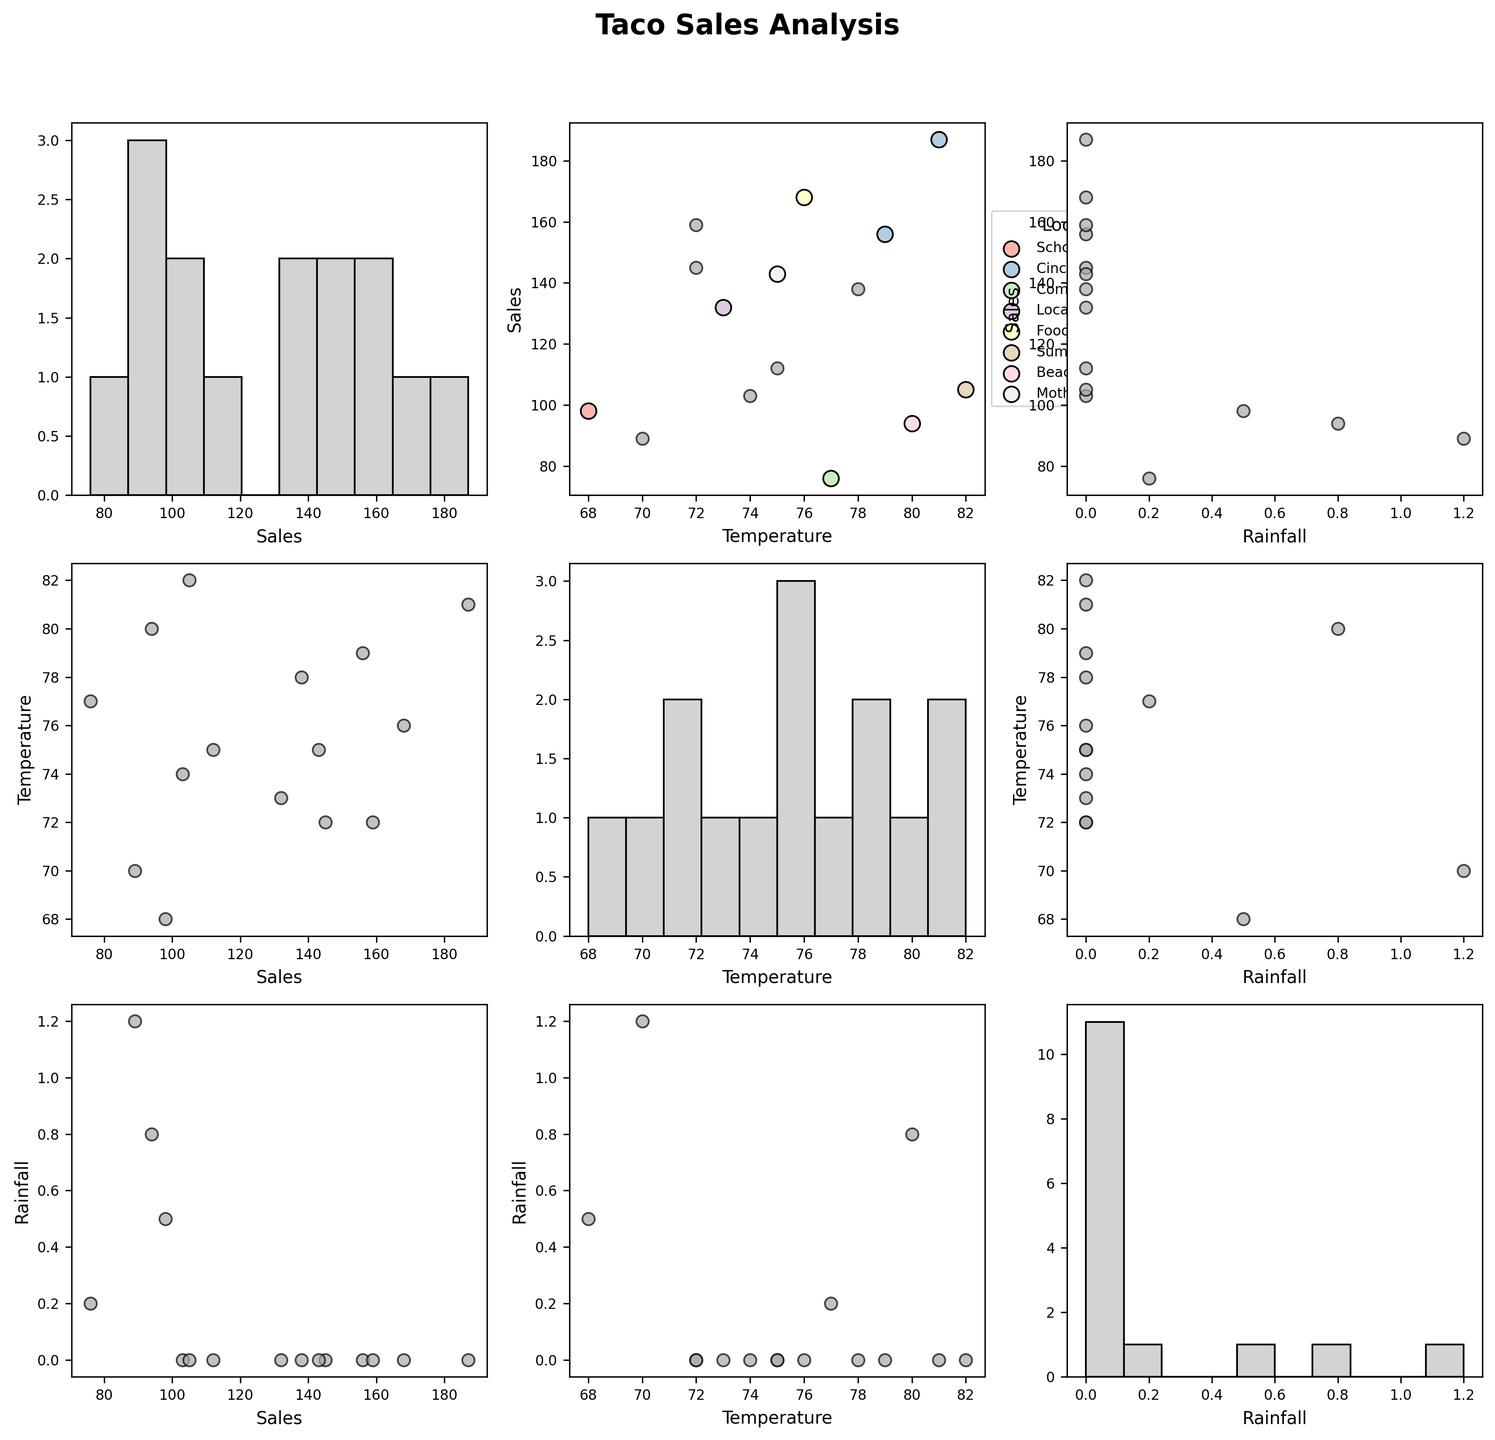What is the title of the figure? The title is usually located at the top center of the figure. It gives an overview of what the figure is about.
Answer: Taco Sales Analysis How many variables are displayed in the figure? By counting the number of different plot sections, each assigned to a variable along the axes, we can determine the number of variables displayed.
Answer: 3 Which variable is on the x-axis for the scatter plot in the first row, second column? The first row, second column plot correlates the first row variable with the second column variable as the scatter plot. Looking at the labels, this plot displays the Temperature on the x-axis.
Answer: Temperature On days with local events, do sales tend to be higher or lower? In the scatter plot matrix, check the labeled points and their Sales values corresponding to local events. Generally, events are plotted using a specific color and can be observed on the legend. Higher sales tend to show a clustering above 130 Sales.
Answer: Higher What is the most frequent rainfall value range observed in the histogram? Find the Rainfall histogram and observe the frequency of occurrence along the x-axis. The highest bar gives the most frequent range, which is zero in this case.
Answer: 0 Which Local Event had the highest Sales? Locate the points with different colors for events in the scatter plots against Sales on the y-axis. Carnival Festival shows the uppermost clustered high Sales around 180.
Answer: Cinco de Mayo Festival What is the relationship between Sales and Temperature? Look for the scatter plot with Sales on the y-axis and Temperature on the x-axis, then observe the trend of the plotted points. They generally show a positive correlation, with Sales increasing with Temperature.
Answer: Positive correlation For days without local events, what is the median value of Sales? First, identify and ignore points with any Local Event other than 'None', then sort the remaining Sales values: [76, 89, 94, 103, 112, 138, 143, 145, 159]. The median is the middle value.
Answer: 138 Which variable seems to impact Sales the most? Compare the scatter plots of Sales against Temperature and Rainfall. The pattern showing strong correlation tends to indicate prominent influence. Temperature scatter plots indicate a clearer pattern of impact.
Answer: Temperature Are there any days when Sales were below 100? In the histogram of Sales or in scatter plots where Sales is the y-axis, count the number of occurrences below 100. These appear as points towards the lower end in the scatter plots. There are [Pollo-98, Vegetariano-76, Lengua-89, Pescado-94] in the sales.
Answer: Yes, 4 days 